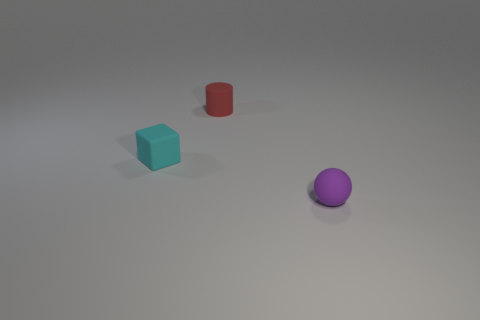How many objects are either tiny cyan rubber blocks or small red cylinders?
Make the answer very short. 2. How many other objects are the same color as the ball?
Keep it short and to the point. 0. What is the shape of the purple object that is the same size as the red cylinder?
Your answer should be very brief. Sphere. There is a small rubber cube left of the red object; what is its color?
Keep it short and to the point. Cyan. What number of things are rubber things that are behind the small matte sphere or objects that are behind the rubber sphere?
Ensure brevity in your answer.  2. Is the ball the same size as the rubber cube?
Your response must be concise. Yes. What number of cylinders are either tiny cyan things or small red objects?
Your answer should be very brief. 1. How many objects are behind the purple sphere and right of the small rubber cylinder?
Offer a terse response. 0. Does the matte cube have the same size as the object right of the small red matte object?
Offer a very short reply. Yes. There is a object that is in front of the small thing on the left side of the tiny red cylinder; are there any objects that are behind it?
Provide a short and direct response. Yes. 